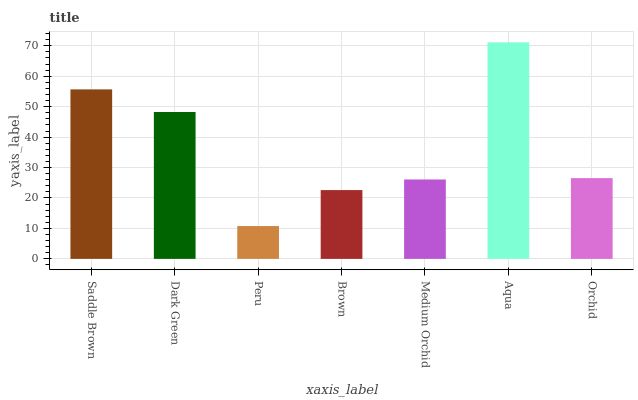Is Peru the minimum?
Answer yes or no. Yes. Is Aqua the maximum?
Answer yes or no. Yes. Is Dark Green the minimum?
Answer yes or no. No. Is Dark Green the maximum?
Answer yes or no. No. Is Saddle Brown greater than Dark Green?
Answer yes or no. Yes. Is Dark Green less than Saddle Brown?
Answer yes or no. Yes. Is Dark Green greater than Saddle Brown?
Answer yes or no. No. Is Saddle Brown less than Dark Green?
Answer yes or no. No. Is Orchid the high median?
Answer yes or no. Yes. Is Orchid the low median?
Answer yes or no. Yes. Is Dark Green the high median?
Answer yes or no. No. Is Brown the low median?
Answer yes or no. No. 